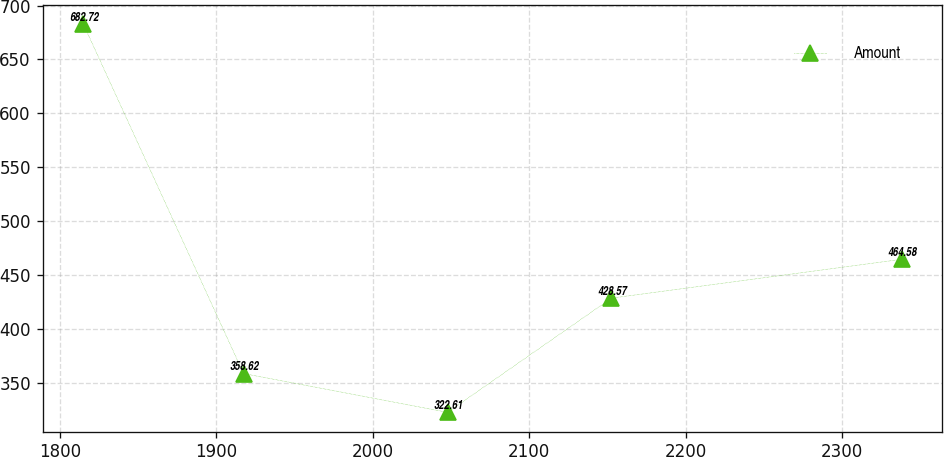Convert chart to OTSL. <chart><loc_0><loc_0><loc_500><loc_500><line_chart><ecel><fcel>Amount<nl><fcel>1815.05<fcel>682.72<nl><fcel>1917.42<fcel>358.62<nl><fcel>2047.84<fcel>322.61<nl><fcel>2152.63<fcel>428.57<nl><fcel>2338.07<fcel>464.58<nl></chart> 